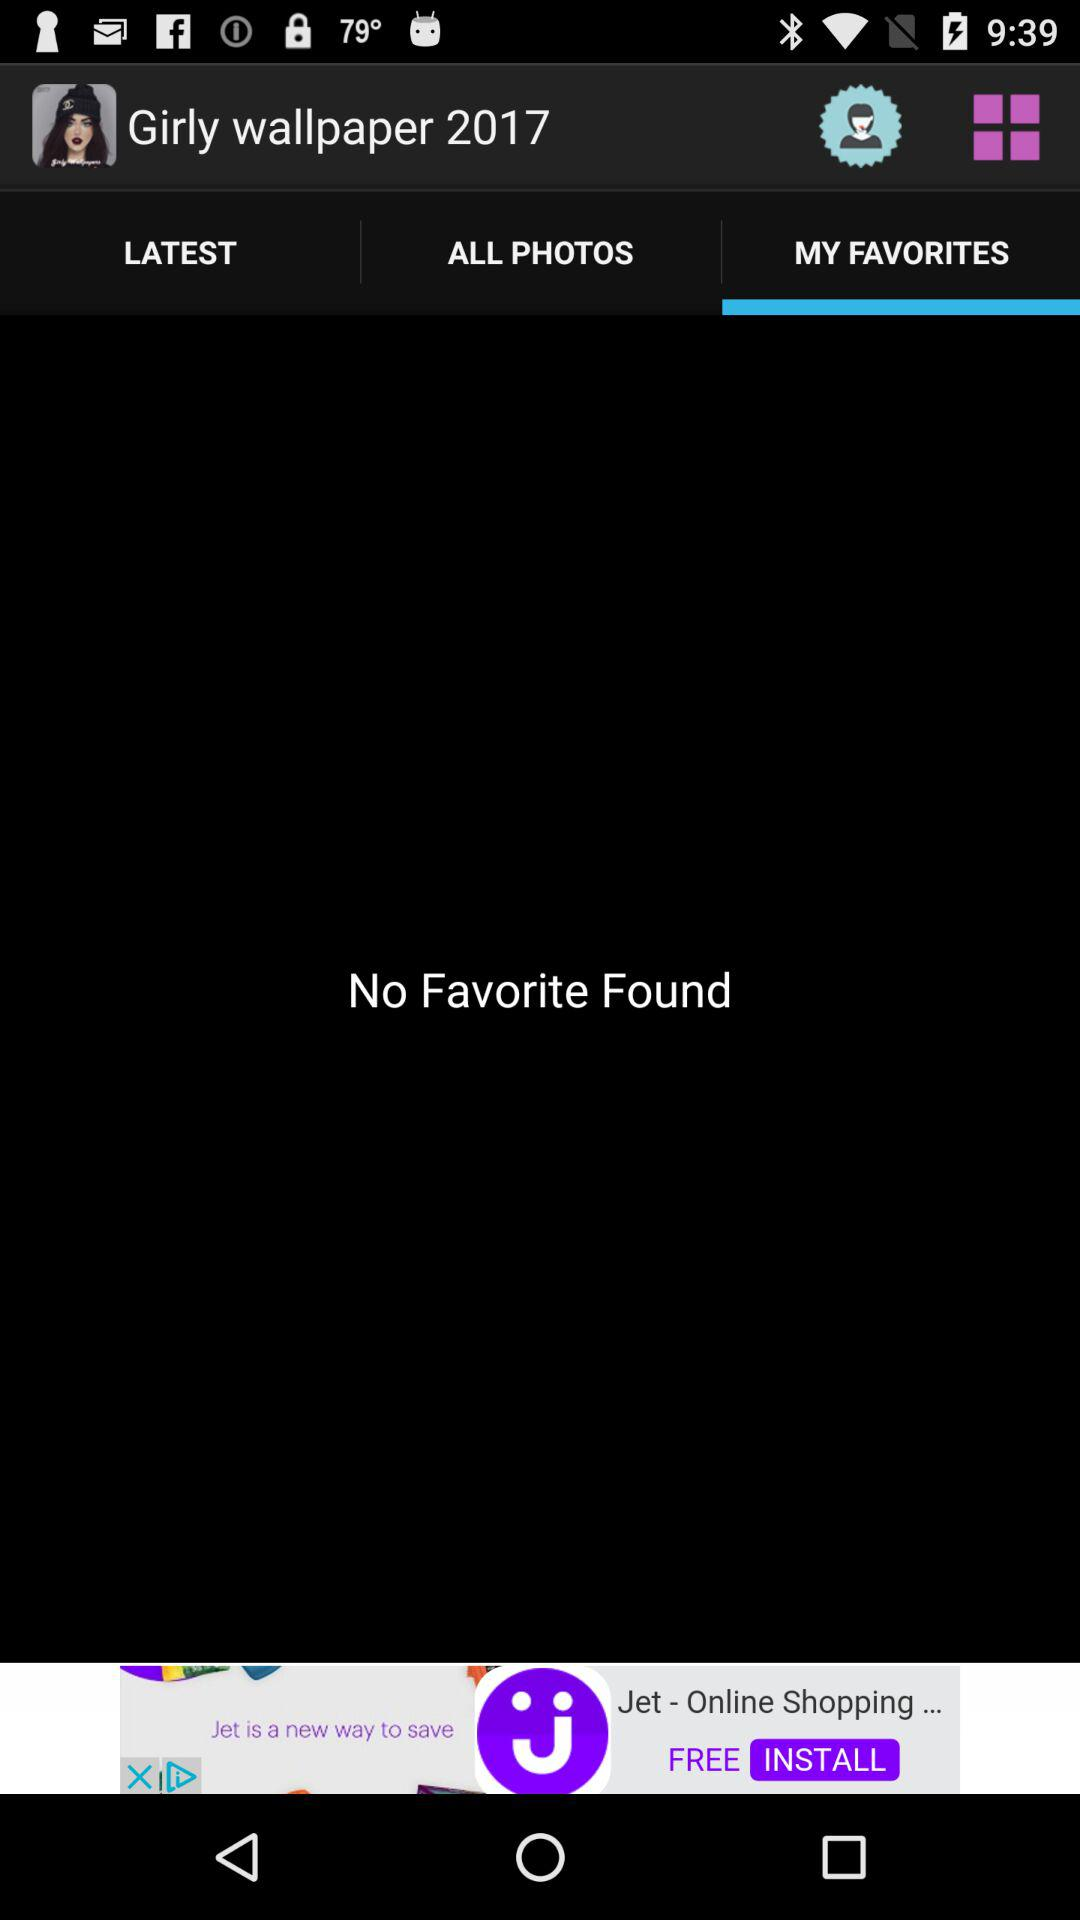How many favorites are there in "Girly wallpapers 2017"? There are no favorites. 